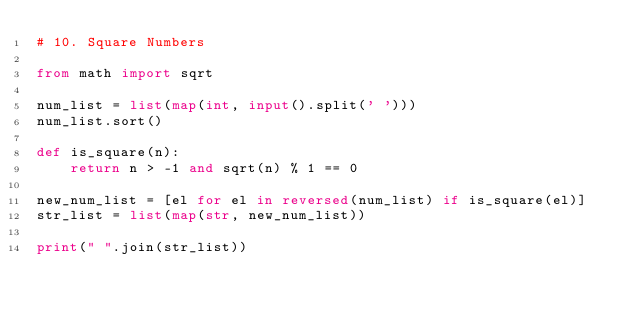Convert code to text. <code><loc_0><loc_0><loc_500><loc_500><_Python_># 10. Square Numbers

from math import sqrt

num_list = list(map(int, input().split(' ')))
num_list.sort()

def is_square(n):
    return n > -1 and sqrt(n) % 1 == 0

new_num_list = [el for el in reversed(num_list) if is_square(el)]
str_list = list(map(str, new_num_list))

print(" ".join(str_list))</code> 